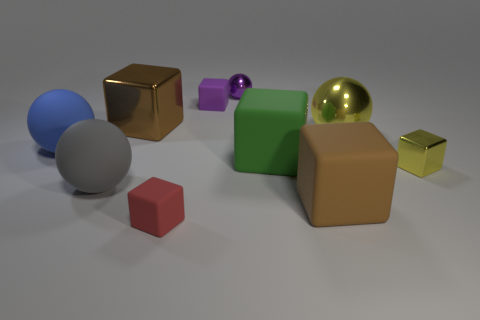Subtract all big matte cubes. How many cubes are left? 4 Subtract all purple blocks. How many blocks are left? 5 Subtract all blocks. How many objects are left? 4 Subtract 0 brown spheres. How many objects are left? 10 Subtract 6 cubes. How many cubes are left? 0 Subtract all green cubes. Subtract all yellow cylinders. How many cubes are left? 5 Subtract all yellow cubes. How many purple balls are left? 1 Subtract all big brown metallic things. Subtract all yellow objects. How many objects are left? 7 Add 6 green rubber cubes. How many green rubber cubes are left? 7 Add 8 tiny blue matte balls. How many tiny blue matte balls exist? 8 